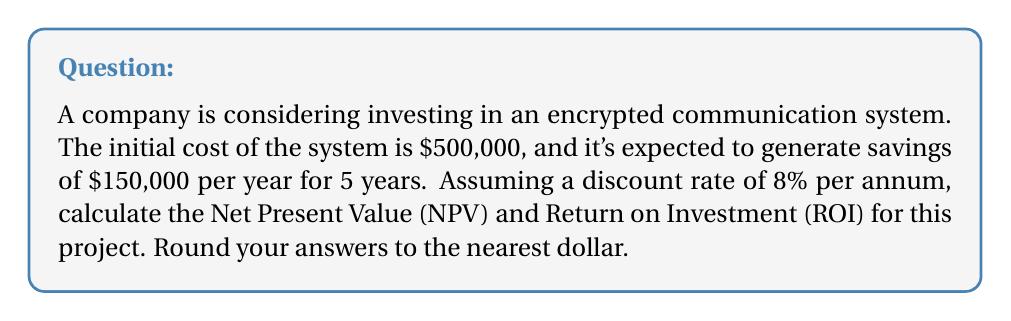Can you answer this question? Step 1: Calculate the Present Value (PV) of future cash flows
Using the formula for Present Value of an Annuity:
$$ PV = A \cdot \frac{1 - (1+r)^{-n}}{r} $$
Where:
A = Annual savings = $150,000
r = Discount rate = 8% = 0.08
n = Number of years = 5

$$ PV = 150,000 \cdot \frac{1 - (1+0.08)^{-5}}{0.08} = 589,499.45 $$

Step 2: Calculate Net Present Value (NPV)
$$ NPV = PV - \text{Initial Investment} $$
$$ NPV = 589,499.45 - 500,000 = 89,499.45 $$

Step 3: Calculate Return on Investment (ROI)
$$ ROI = \frac{\text{Net Profit}}{\text{Cost of Investment}} \cdot 100\% $$
$$ ROI = \frac{89,499.45}{500,000} \cdot 100\% = 17.90\% $$

Rounding to the nearest dollar:
NPV = $89,499
ROI = 17.90%
Answer: NPV: $89,499, ROI: 17.90% 